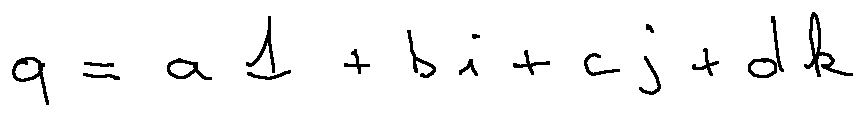<formula> <loc_0><loc_0><loc_500><loc_500>q = a 1 + b i + c j + d k</formula> 